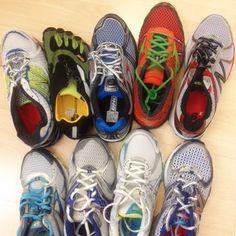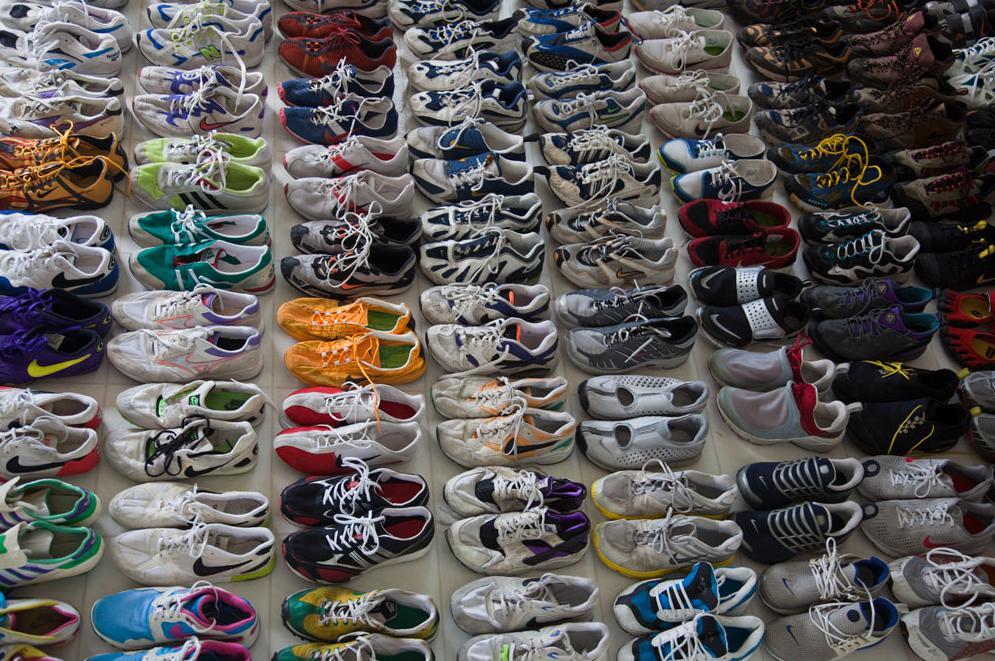The first image is the image on the left, the second image is the image on the right. Given the left and right images, does the statement "The shoes are arranged neatly on shelves in one of the iamges." hold true? Answer yes or no. No. 